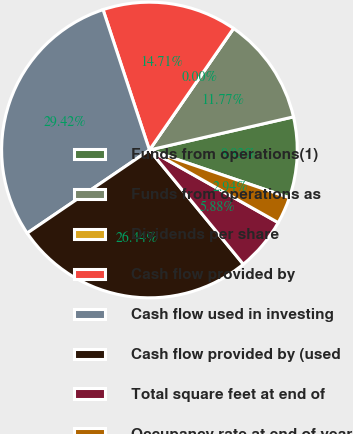Convert chart to OTSL. <chart><loc_0><loc_0><loc_500><loc_500><pie_chart><fcel>Funds from operations(1)<fcel>Funds from operations as<fcel>Dividends per share<fcel>Cash flow provided by<fcel>Cash flow used in investing<fcel>Cash flow provided by (used<fcel>Total square feet at end of<fcel>Occupancy rate at end of year<nl><fcel>8.83%<fcel>11.77%<fcel>0.0%<fcel>14.71%<fcel>29.42%<fcel>26.44%<fcel>5.88%<fcel>2.94%<nl></chart> 